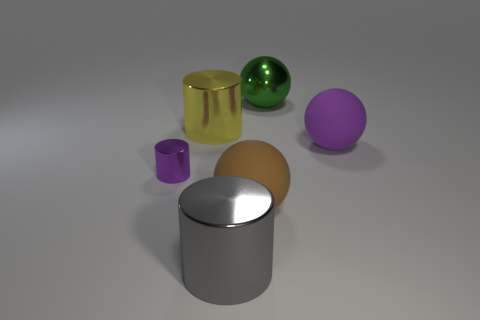What number of other things are there of the same color as the metal ball?
Offer a very short reply. 0. Is the number of big yellow things that are to the right of the brown object greater than the number of gray metallic blocks?
Give a very brief answer. No. Are there any tiny objects of the same color as the tiny shiny cylinder?
Provide a short and direct response. No. What size is the yellow thing?
Your answer should be very brief. Large. Does the large metallic sphere have the same color as the small cylinder?
Offer a very short reply. No. How many things are either large objects or metallic cylinders that are left of the yellow object?
Keep it short and to the point. 6. How many large objects are right of the big sphere to the left of the ball behind the purple matte thing?
Your answer should be very brief. 2. There is a ball that is the same color as the tiny metallic cylinder; what is it made of?
Keep it short and to the point. Rubber. How many green matte cylinders are there?
Provide a succinct answer. 0. Is the size of the shiny object right of the gray cylinder the same as the gray shiny object?
Provide a succinct answer. Yes. 